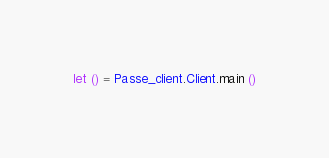Convert code to text. <code><loc_0><loc_0><loc_500><loc_500><_OCaml_>let () = Passe_client.Client.main ()
</code> 